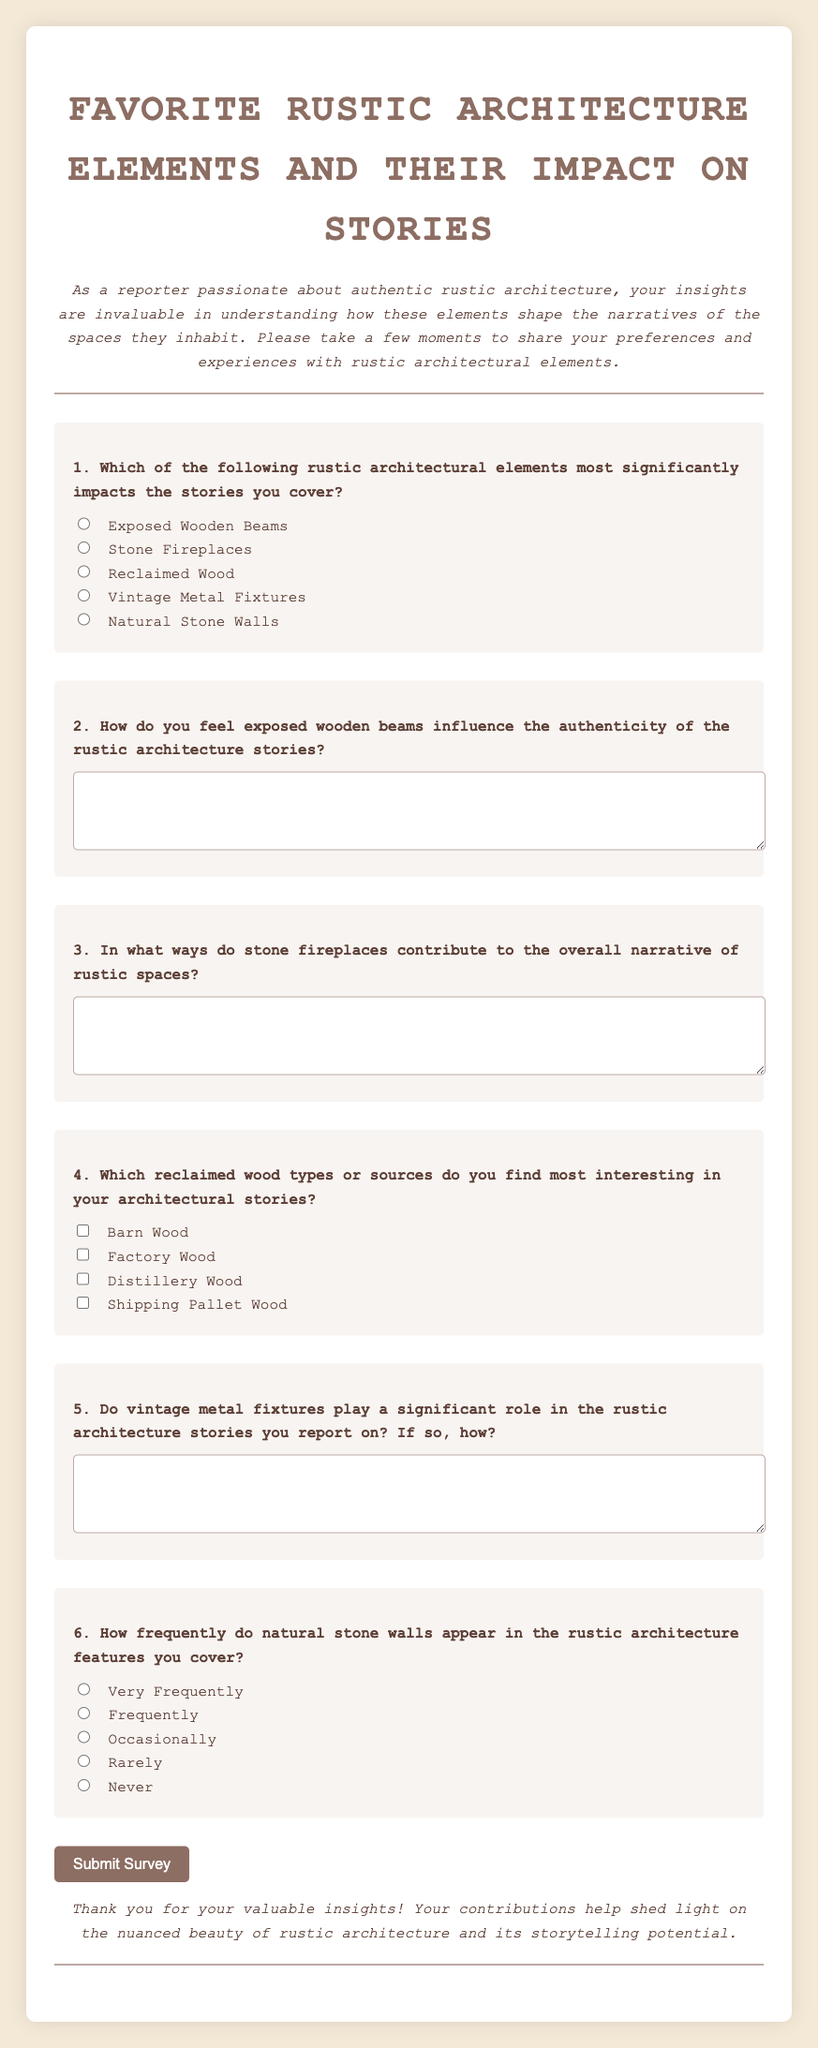What is the title of the survey? The title is prominently displayed at the top of the document, indicating the subject of the survey.
Answer: Favorite Rustic Architecture Elements and Their Impact on Stories How many questions are included in the survey? The survey consists of six questions, each addressing different aspects of rustic architecture.
Answer: 6 What is one of the options for Question 1 regarding rustic architectural elements? The options for Question 1 are listed below the question, providing various elements to choose from.
Answer: Exposed Wooden Beams What type of text area is used for Question 2? The format for Question 2 is a text area that allows for detailed written feedback from respondents.
Answer: Textarea What is the background color of the body in the document? The document's styling specifies a background color, contributing to the overall aesthetic appeal.
Answer: #f4e9d7 How many reclaimed wood types can participants select in Question 4? The question provides several options for respondents to select multiple reclaimed wood sources they find interesting.
Answer: 4 